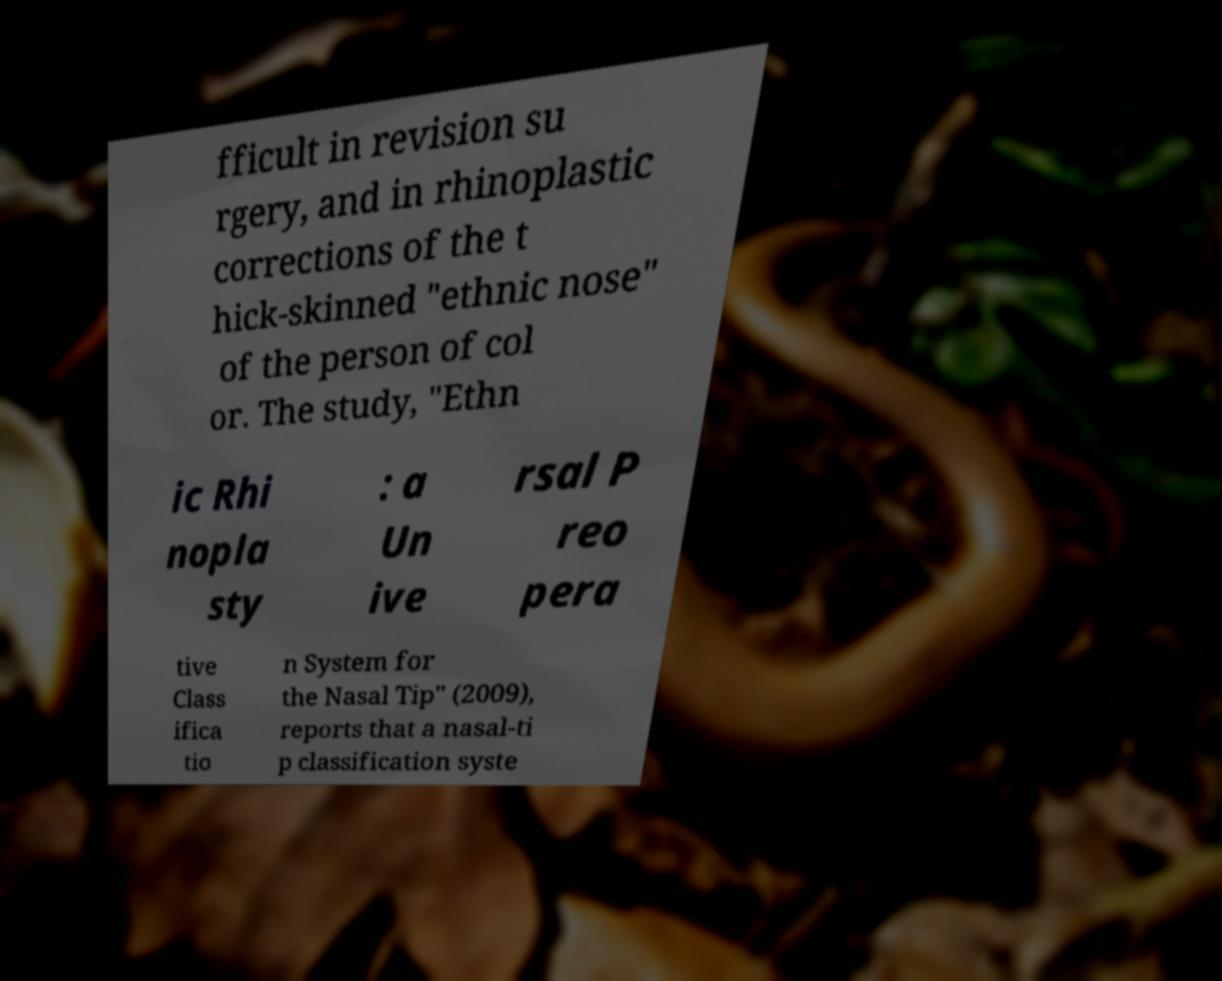There's text embedded in this image that I need extracted. Can you transcribe it verbatim? fficult in revision su rgery, and in rhinoplastic corrections of the t hick-skinned "ethnic nose" of the person of col or. The study, "Ethn ic Rhi nopla sty : a Un ive rsal P reo pera tive Class ifica tio n System for the Nasal Tip" (2009), reports that a nasal-ti p classification syste 